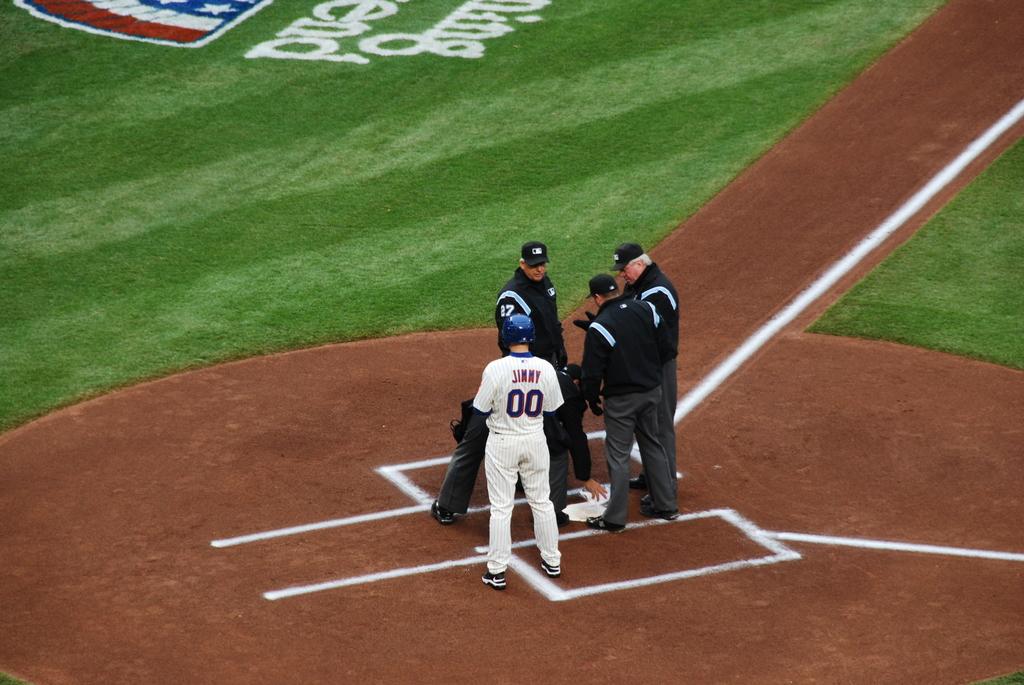What is the player in white's number?
Ensure brevity in your answer.  00. 